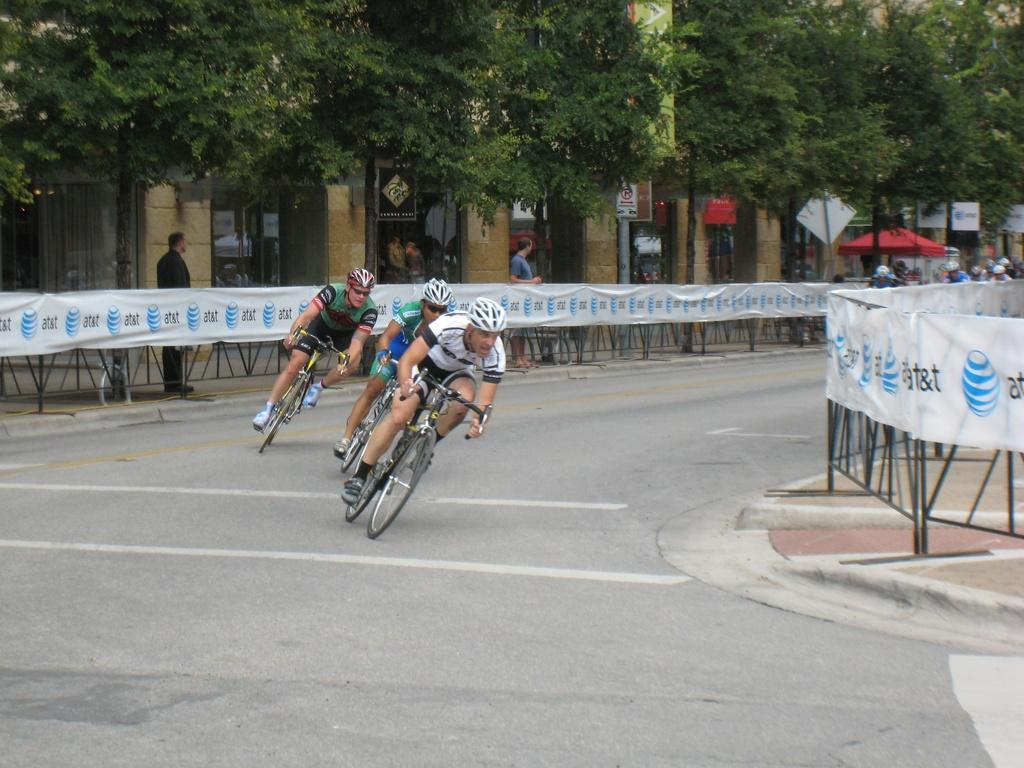How many people are in the image? There are three persons in the image. What are the persons doing in the image? The persons are riding bicycles. What can be seen in the background of the image? There is a fence, people, and trees in the background of the image. Can you see any visible veins on the bicycles in the image? There are no visible veins on the bicycles in the image, as bicycles do not have veins. 